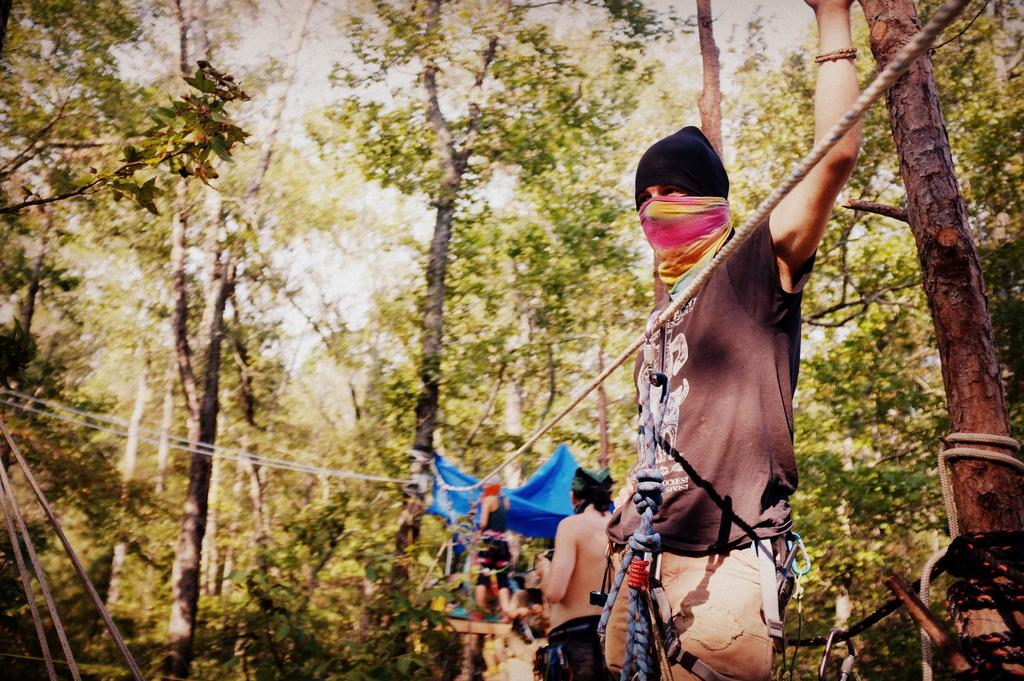Who or what is present in the image? There is a person in the image. What is the person holding? The person is holding an object. Can you describe any other items in the image? There is a rope, a tent, and a tree in the image. What note is the person singing in the image? There is no indication in the image that the person is singing, so it cannot be determined from the picture. 